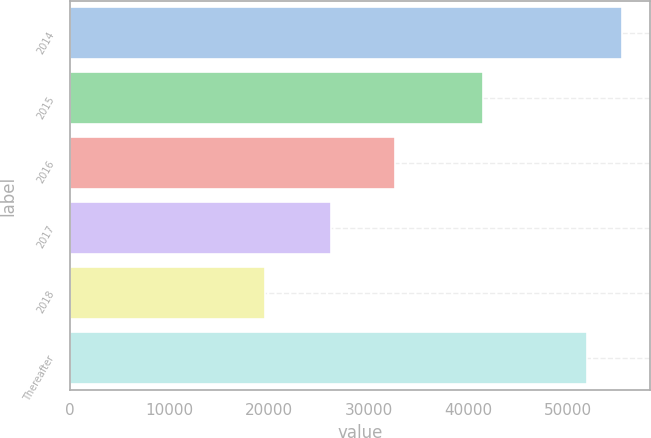<chart> <loc_0><loc_0><loc_500><loc_500><bar_chart><fcel>2014<fcel>2015<fcel>2016<fcel>2017<fcel>2018<fcel>Thereafter<nl><fcel>55399.6<fcel>41420<fcel>32610<fcel>26159<fcel>19557<fcel>51893<nl></chart> 